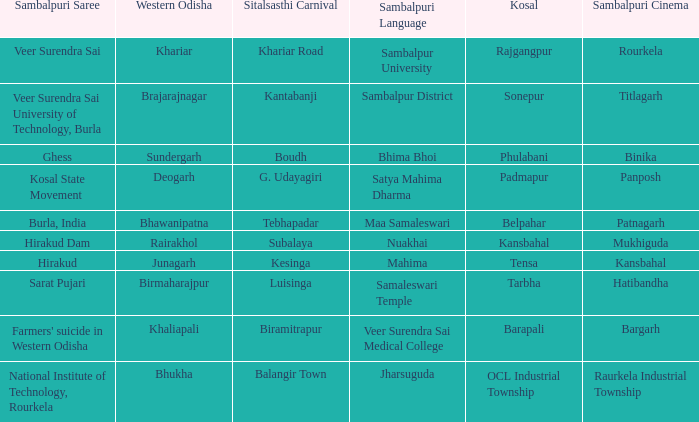What is the kosal with hatibandha as the sambalpuri cinema? Tarbha. 